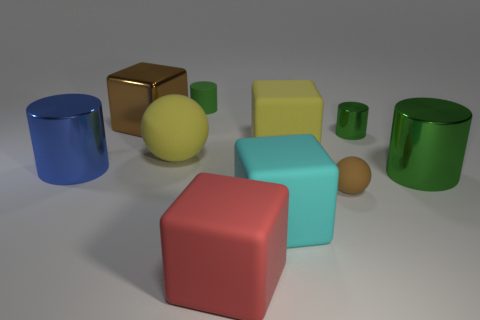What is the size of the red thing?
Ensure brevity in your answer.  Large. What is the material of the large green object that is the same shape as the small green rubber thing?
Ensure brevity in your answer.  Metal. Is there any other thing that is the same material as the yellow block?
Your answer should be very brief. Yes. Are there the same number of matte things on the left side of the brown rubber sphere and yellow rubber things behind the tiny shiny cylinder?
Provide a succinct answer. No. Does the cyan block have the same material as the big brown block?
Your answer should be compact. No. How many gray objects are metal objects or matte cylinders?
Offer a very short reply. 0. How many small brown things are the same shape as the red matte thing?
Your answer should be very brief. 0. What is the large blue thing made of?
Your answer should be very brief. Metal. Is the number of large cyan rubber objects that are behind the tiny matte ball the same as the number of gray spheres?
Offer a very short reply. Yes. There is a cyan thing that is the same size as the blue shiny object; what shape is it?
Offer a very short reply. Cube. 